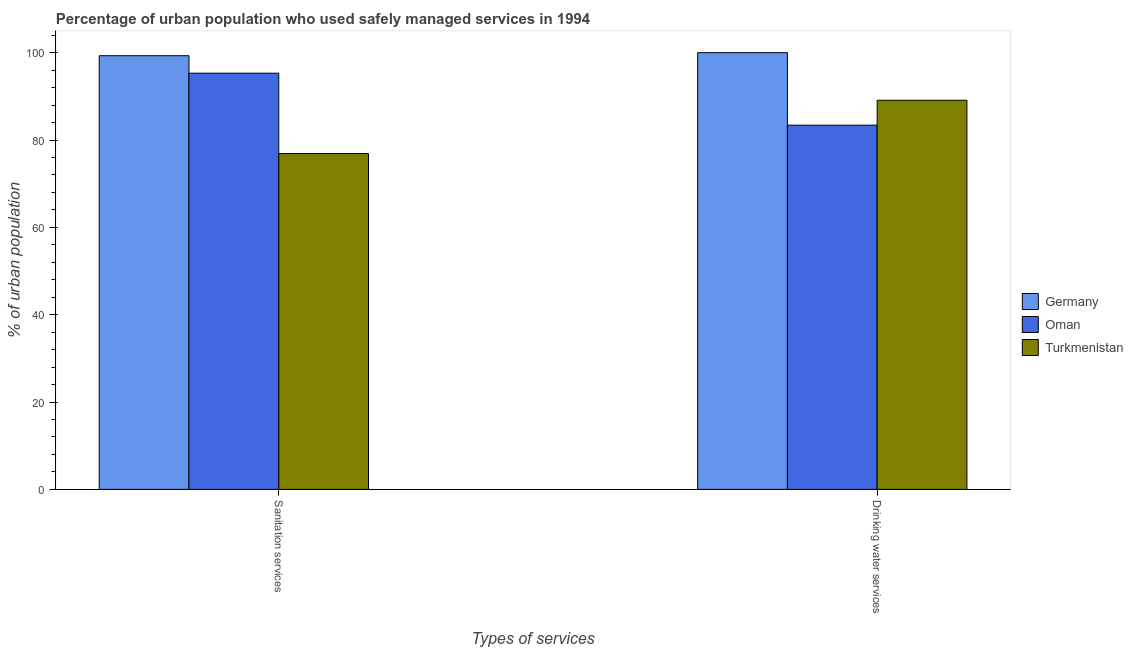How many different coloured bars are there?
Make the answer very short. 3. What is the label of the 1st group of bars from the left?
Your response must be concise. Sanitation services. What is the percentage of urban population who used sanitation services in Oman?
Your response must be concise. 95.3. Across all countries, what is the maximum percentage of urban population who used sanitation services?
Give a very brief answer. 99.3. Across all countries, what is the minimum percentage of urban population who used drinking water services?
Keep it short and to the point. 83.4. In which country was the percentage of urban population who used sanitation services minimum?
Offer a terse response. Turkmenistan. What is the total percentage of urban population who used sanitation services in the graph?
Offer a terse response. 271.5. What is the difference between the percentage of urban population who used drinking water services in Turkmenistan and that in Germany?
Keep it short and to the point. -10.9. What is the difference between the percentage of urban population who used sanitation services in Turkmenistan and the percentage of urban population who used drinking water services in Germany?
Your answer should be compact. -23.1. What is the average percentage of urban population who used drinking water services per country?
Provide a succinct answer. 90.83. What is the difference between the percentage of urban population who used drinking water services and percentage of urban population who used sanitation services in Turkmenistan?
Keep it short and to the point. 12.2. In how many countries, is the percentage of urban population who used drinking water services greater than 36 %?
Your answer should be very brief. 3. What is the ratio of the percentage of urban population who used drinking water services in Turkmenistan to that in Oman?
Keep it short and to the point. 1.07. In how many countries, is the percentage of urban population who used sanitation services greater than the average percentage of urban population who used sanitation services taken over all countries?
Make the answer very short. 2. What does the 1st bar from the left in Sanitation services represents?
Your answer should be very brief. Germany. What does the 2nd bar from the right in Sanitation services represents?
Your answer should be very brief. Oman. How many bars are there?
Provide a succinct answer. 6. Are all the bars in the graph horizontal?
Your response must be concise. No. How many countries are there in the graph?
Give a very brief answer. 3. What is the difference between two consecutive major ticks on the Y-axis?
Ensure brevity in your answer.  20. Are the values on the major ticks of Y-axis written in scientific E-notation?
Make the answer very short. No. Does the graph contain any zero values?
Your answer should be compact. No. Where does the legend appear in the graph?
Ensure brevity in your answer.  Center right. How many legend labels are there?
Keep it short and to the point. 3. What is the title of the graph?
Provide a succinct answer. Percentage of urban population who used safely managed services in 1994. What is the label or title of the X-axis?
Offer a very short reply. Types of services. What is the label or title of the Y-axis?
Provide a short and direct response. % of urban population. What is the % of urban population in Germany in Sanitation services?
Your answer should be compact. 99.3. What is the % of urban population of Oman in Sanitation services?
Offer a very short reply. 95.3. What is the % of urban population in Turkmenistan in Sanitation services?
Offer a terse response. 76.9. What is the % of urban population of Oman in Drinking water services?
Offer a very short reply. 83.4. What is the % of urban population in Turkmenistan in Drinking water services?
Your response must be concise. 89.1. Across all Types of services, what is the maximum % of urban population in Oman?
Provide a succinct answer. 95.3. Across all Types of services, what is the maximum % of urban population of Turkmenistan?
Offer a very short reply. 89.1. Across all Types of services, what is the minimum % of urban population in Germany?
Provide a short and direct response. 99.3. Across all Types of services, what is the minimum % of urban population in Oman?
Make the answer very short. 83.4. Across all Types of services, what is the minimum % of urban population of Turkmenistan?
Give a very brief answer. 76.9. What is the total % of urban population in Germany in the graph?
Provide a short and direct response. 199.3. What is the total % of urban population in Oman in the graph?
Offer a very short reply. 178.7. What is the total % of urban population of Turkmenistan in the graph?
Ensure brevity in your answer.  166. What is the difference between the % of urban population in Germany in Sanitation services and that in Drinking water services?
Offer a terse response. -0.7. What is the difference between the % of urban population in Oman in Sanitation services and that in Drinking water services?
Give a very brief answer. 11.9. What is the difference between the % of urban population in Germany in Sanitation services and the % of urban population in Oman in Drinking water services?
Provide a short and direct response. 15.9. What is the difference between the % of urban population in Oman in Sanitation services and the % of urban population in Turkmenistan in Drinking water services?
Your answer should be very brief. 6.2. What is the average % of urban population in Germany per Types of services?
Your answer should be compact. 99.65. What is the average % of urban population of Oman per Types of services?
Keep it short and to the point. 89.35. What is the difference between the % of urban population in Germany and % of urban population in Turkmenistan in Sanitation services?
Ensure brevity in your answer.  22.4. What is the difference between the % of urban population of Oman and % of urban population of Turkmenistan in Sanitation services?
Your response must be concise. 18.4. What is the difference between the % of urban population of Germany and % of urban population of Oman in Drinking water services?
Offer a terse response. 16.6. What is the difference between the % of urban population of Oman and % of urban population of Turkmenistan in Drinking water services?
Your answer should be compact. -5.7. What is the ratio of the % of urban population in Germany in Sanitation services to that in Drinking water services?
Ensure brevity in your answer.  0.99. What is the ratio of the % of urban population of Oman in Sanitation services to that in Drinking water services?
Your response must be concise. 1.14. What is the ratio of the % of urban population in Turkmenistan in Sanitation services to that in Drinking water services?
Keep it short and to the point. 0.86. What is the difference between the highest and the second highest % of urban population of Germany?
Make the answer very short. 0.7. What is the difference between the highest and the second highest % of urban population of Turkmenistan?
Keep it short and to the point. 12.2. What is the difference between the highest and the lowest % of urban population in Oman?
Offer a terse response. 11.9. 